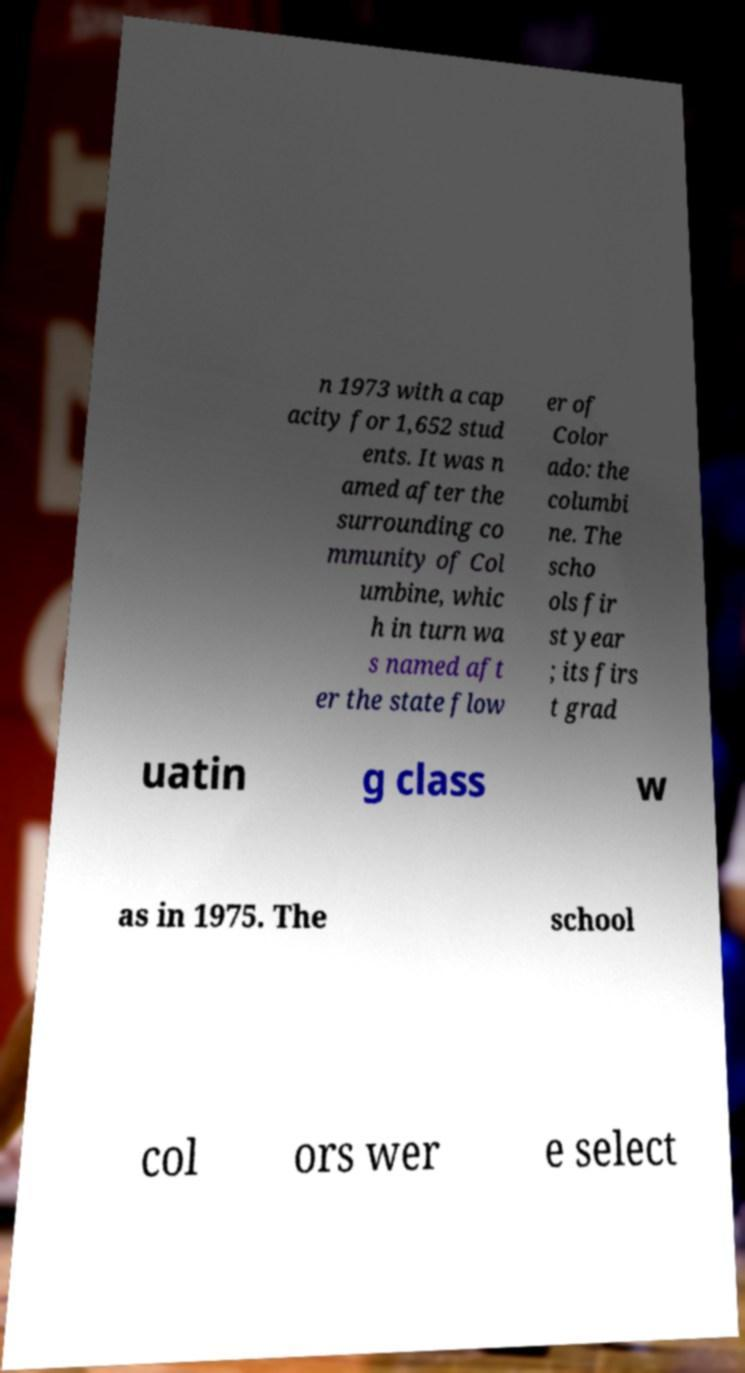Could you extract and type out the text from this image? n 1973 with a cap acity for 1,652 stud ents. It was n amed after the surrounding co mmunity of Col umbine, whic h in turn wa s named aft er the state flow er of Color ado: the columbi ne. The scho ols fir st year ; its firs t grad uatin g class w as in 1975. The school col ors wer e select 